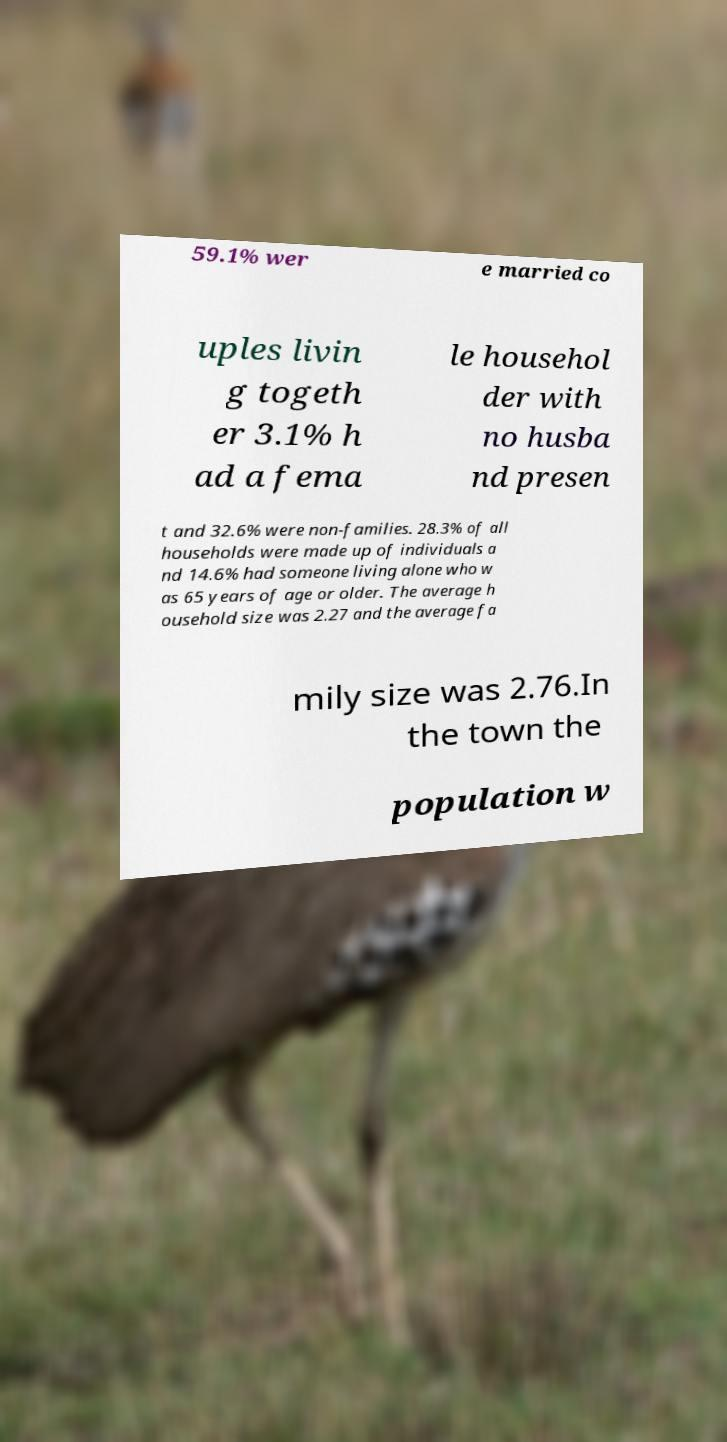What messages or text are displayed in this image? I need them in a readable, typed format. 59.1% wer e married co uples livin g togeth er 3.1% h ad a fema le househol der with no husba nd presen t and 32.6% were non-families. 28.3% of all households were made up of individuals a nd 14.6% had someone living alone who w as 65 years of age or older. The average h ousehold size was 2.27 and the average fa mily size was 2.76.In the town the population w 